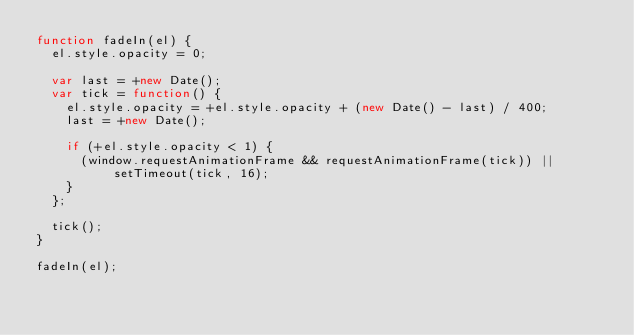Convert code to text. <code><loc_0><loc_0><loc_500><loc_500><_JavaScript_>function fadeIn(el) {
  el.style.opacity = 0;

  var last = +new Date();
  var tick = function() {
    el.style.opacity = +el.style.opacity + (new Date() - last) / 400;
    last = +new Date();

    if (+el.style.opacity < 1) {
      (window.requestAnimationFrame && requestAnimationFrame(tick)) || setTimeout(tick, 16);
    }
  };

  tick();
}

fadeIn(el);
</code> 